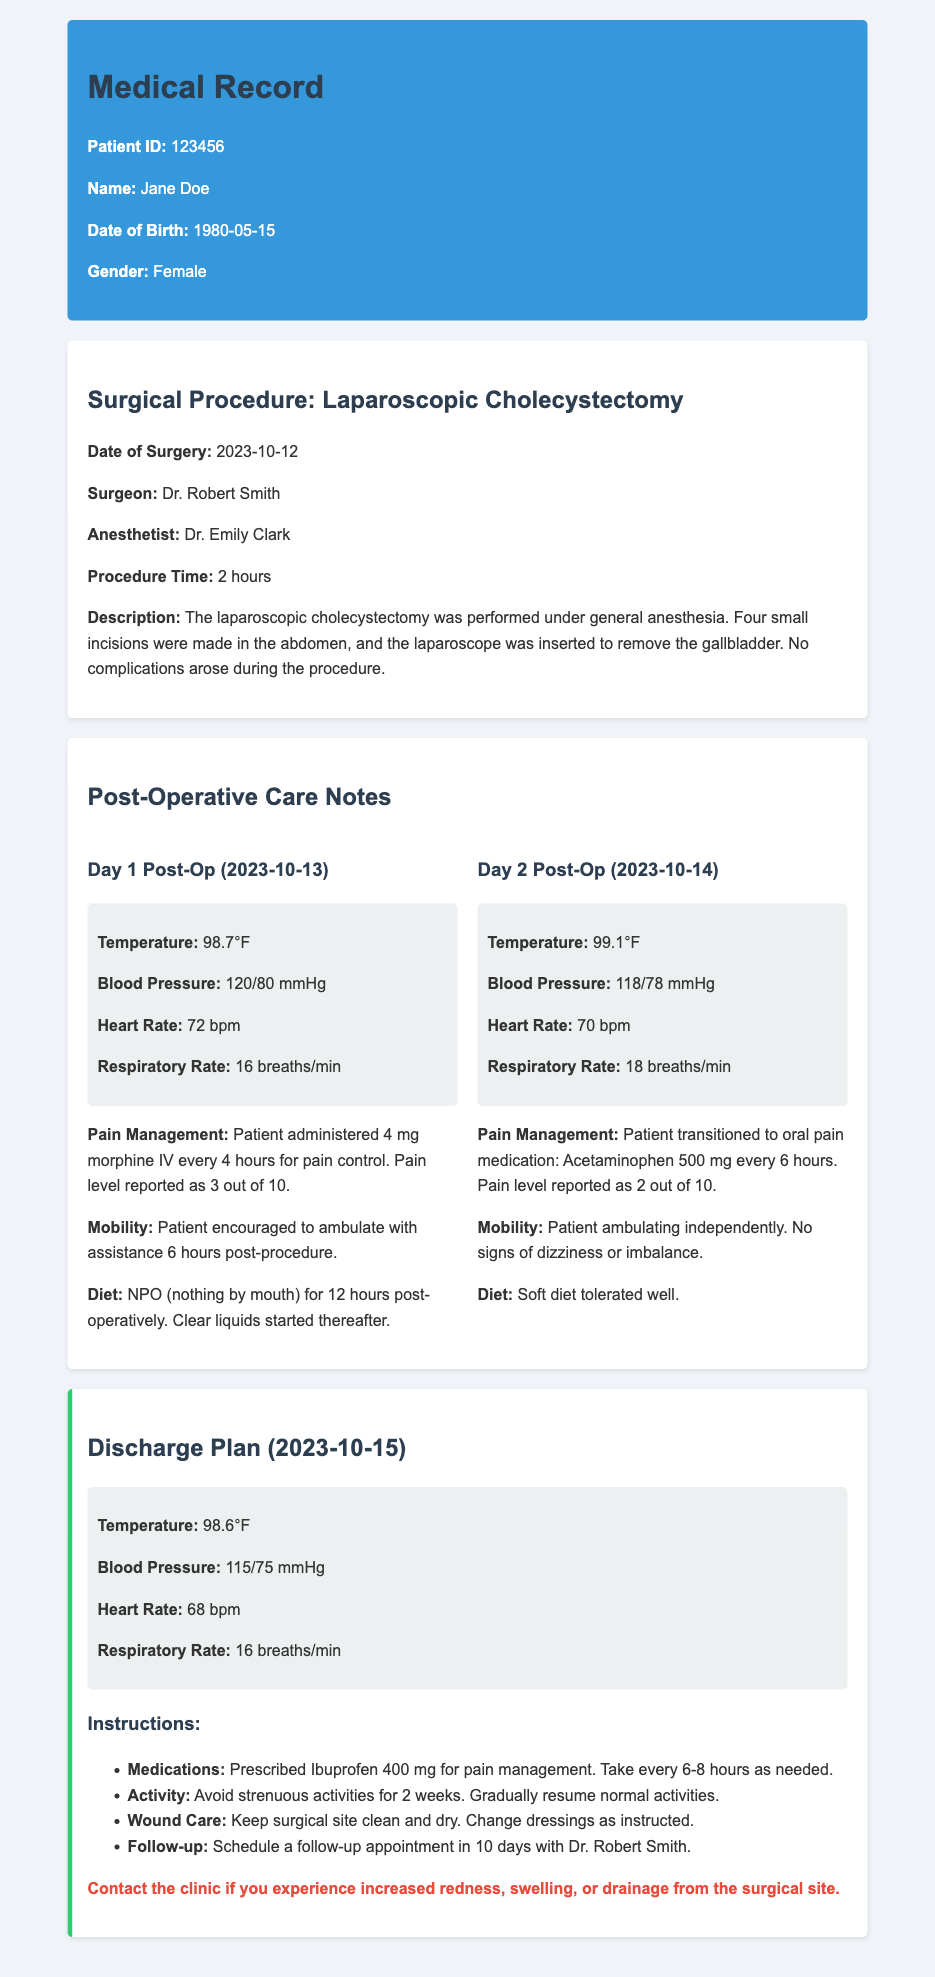What was the date of surgery? The date of surgery is listed in the document under the surgical procedure section.
Answer: 2023-10-12 Who was the surgeon? The surgeon's name can be found in the surgical procedure details.
Answer: Dr. Robert Smith What pain medication was prescribed upon discharge? The medications and their purposes are outlined in the discharge plan.
Answer: Ibuprofen 400 mg What was the patient’s blood pressure on Day 1 post-op? Blood pressure figures are provided under vital signs for each post-operative day.
Answer: 120/80 mmHg What instruction is given regarding activity after discharge? Activity guidelines are specified in the discharge plan section.
Answer: Avoid strenuous activities for 2 weeks How long did the surgical procedure take? The procedure time is stated in the details of the surgical procedure.
Answer: 2 hours What was the pain level reported on Day 2 post-op? Patient-reported pain levels are included in the care notes for each post-operative day.
Answer: 2 out of 10 What diet was recommended on Day 1 post-op? Dietary instructions are provided in the post-operative care notes.
Answer: NPO (nothing by mouth) for 12 hours What is the follow-up appointment timeline? The follow-up appointment details are included in the discharge instructions.
Answer: 10 days 